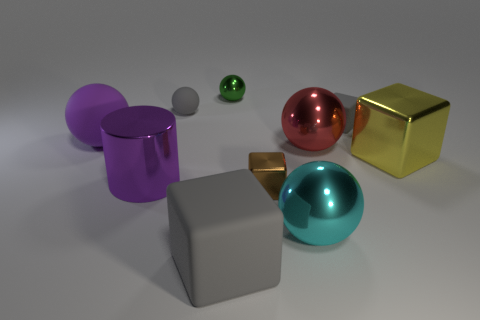Subtract 1 balls. How many balls are left? 4 Subtract all purple spheres. How many spheres are left? 4 Subtract all small gray blocks. How many blocks are left? 3 Subtract 2 gray cubes. How many objects are left? 8 Subtract all cylinders. How many objects are left? 9 Subtract all purple balls. Subtract all gray blocks. How many balls are left? 4 Subtract all blue cylinders. How many yellow balls are left? 0 Subtract all small metallic cubes. Subtract all yellow metallic cubes. How many objects are left? 8 Add 1 large gray rubber objects. How many large gray rubber objects are left? 2 Add 8 large red balls. How many large red balls exist? 9 